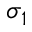<formula> <loc_0><loc_0><loc_500><loc_500>\sigma _ { 1 }</formula> 